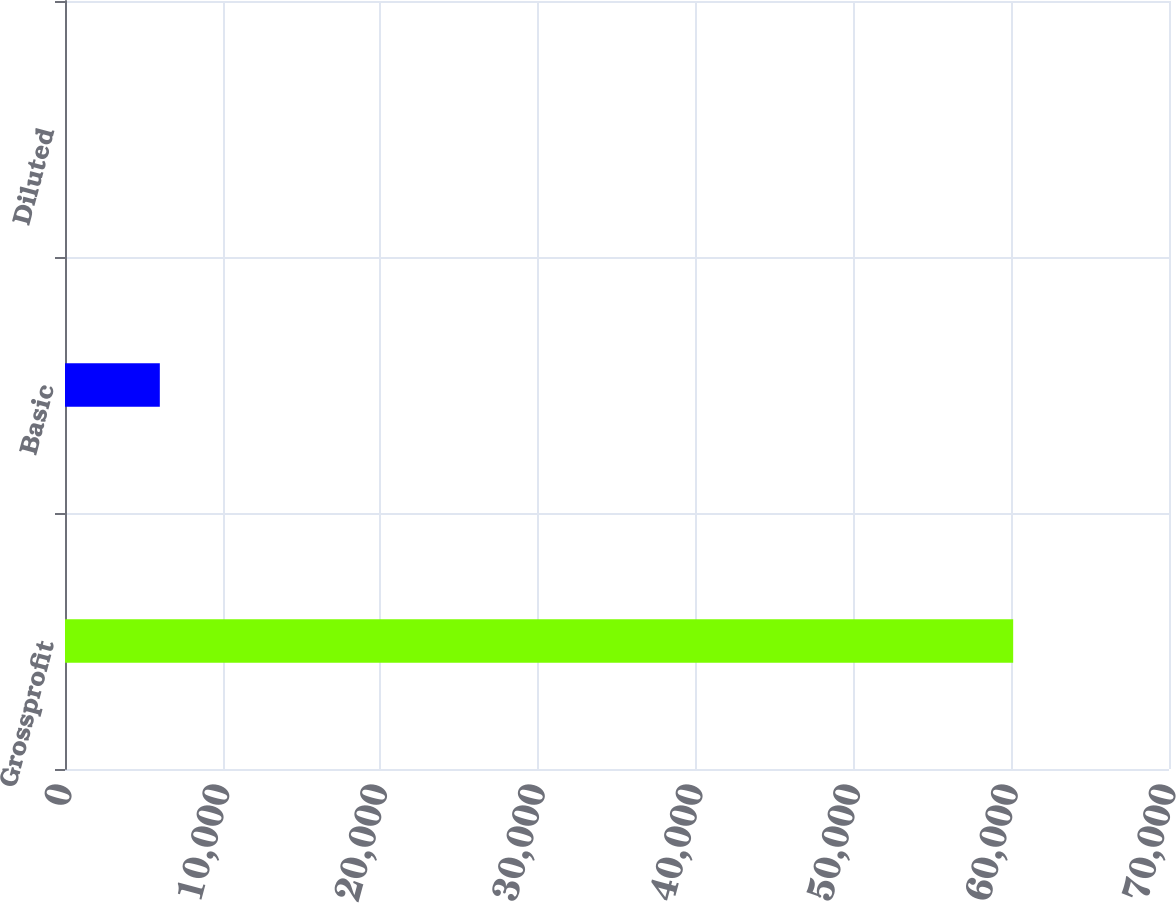<chart> <loc_0><loc_0><loc_500><loc_500><bar_chart><fcel>Grossprofit<fcel>Basic<fcel>Diluted<nl><fcel>60120<fcel>6012.2<fcel>0.22<nl></chart> 